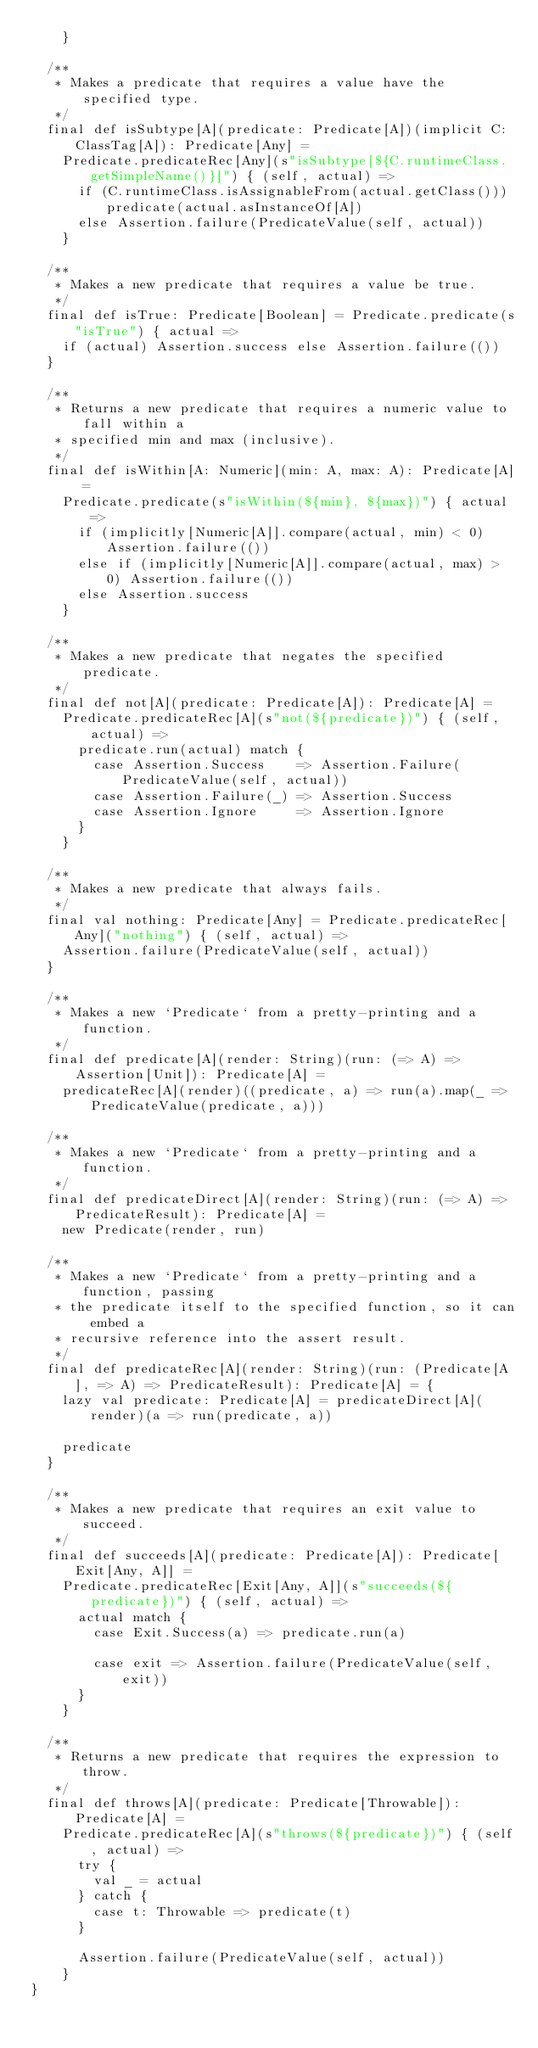Convert code to text. <code><loc_0><loc_0><loc_500><loc_500><_Scala_>    }

  /**
   * Makes a predicate that requires a value have the specified type.
   */
  final def isSubtype[A](predicate: Predicate[A])(implicit C: ClassTag[A]): Predicate[Any] =
    Predicate.predicateRec[Any](s"isSubtype[${C.runtimeClass.getSimpleName()}]") { (self, actual) =>
      if (C.runtimeClass.isAssignableFrom(actual.getClass())) predicate(actual.asInstanceOf[A])
      else Assertion.failure(PredicateValue(self, actual))
    }

  /**
   * Makes a new predicate that requires a value be true.
   */
  final def isTrue: Predicate[Boolean] = Predicate.predicate(s"isTrue") { actual =>
    if (actual) Assertion.success else Assertion.failure(())
  }

  /**
   * Returns a new predicate that requires a numeric value to fall within a
   * specified min and max (inclusive).
   */
  final def isWithin[A: Numeric](min: A, max: A): Predicate[A] =
    Predicate.predicate(s"isWithin(${min}, ${max})") { actual =>
      if (implicitly[Numeric[A]].compare(actual, min) < 0) Assertion.failure(())
      else if (implicitly[Numeric[A]].compare(actual, max) > 0) Assertion.failure(())
      else Assertion.success
    }

  /**
   * Makes a new predicate that negates the specified predicate.
   */
  final def not[A](predicate: Predicate[A]): Predicate[A] =
    Predicate.predicateRec[A](s"not(${predicate})") { (self, actual) =>
      predicate.run(actual) match {
        case Assertion.Success    => Assertion.Failure(PredicateValue(self, actual))
        case Assertion.Failure(_) => Assertion.Success
        case Assertion.Ignore     => Assertion.Ignore
      }
    }

  /**
   * Makes a new predicate that always fails.
   */
  final val nothing: Predicate[Any] = Predicate.predicateRec[Any]("nothing") { (self, actual) =>
    Assertion.failure(PredicateValue(self, actual))
  }

  /**
   * Makes a new `Predicate` from a pretty-printing and a function.
   */
  final def predicate[A](render: String)(run: (=> A) => Assertion[Unit]): Predicate[A] =
    predicateRec[A](render)((predicate, a) => run(a).map(_ => PredicateValue(predicate, a)))

  /**
   * Makes a new `Predicate` from a pretty-printing and a function.
   */
  final def predicateDirect[A](render: String)(run: (=> A) => PredicateResult): Predicate[A] =
    new Predicate(render, run)

  /**
   * Makes a new `Predicate` from a pretty-printing and a function, passing
   * the predicate itself to the specified function, so it can embed a
   * recursive reference into the assert result.
   */
  final def predicateRec[A](render: String)(run: (Predicate[A], => A) => PredicateResult): Predicate[A] = {
    lazy val predicate: Predicate[A] = predicateDirect[A](render)(a => run(predicate, a))

    predicate
  }

  /**
   * Makes a new predicate that requires an exit value to succeed.
   */
  final def succeeds[A](predicate: Predicate[A]): Predicate[Exit[Any, A]] =
    Predicate.predicateRec[Exit[Any, A]](s"succeeds(${predicate})") { (self, actual) =>
      actual match {
        case Exit.Success(a) => predicate.run(a)

        case exit => Assertion.failure(PredicateValue(self, exit))
      }
    }

  /**
   * Returns a new predicate that requires the expression to throw.
   */
  final def throws[A](predicate: Predicate[Throwable]): Predicate[A] =
    Predicate.predicateRec[A](s"throws(${predicate})") { (self, actual) =>
      try {
        val _ = actual
      } catch {
        case t: Throwable => predicate(t)
      }

      Assertion.failure(PredicateValue(self, actual))
    }
}
</code> 